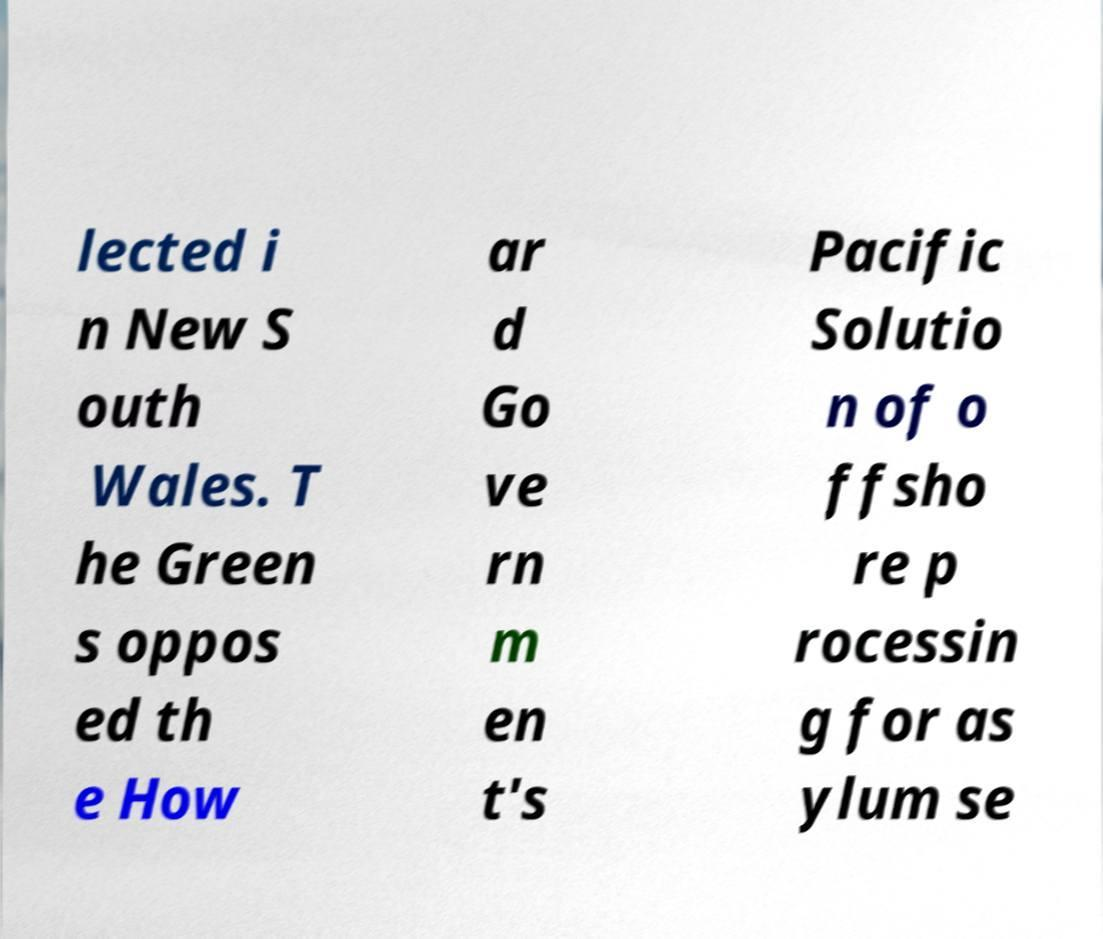Could you assist in decoding the text presented in this image and type it out clearly? lected i n New S outh Wales. T he Green s oppos ed th e How ar d Go ve rn m en t's Pacific Solutio n of o ffsho re p rocessin g for as ylum se 